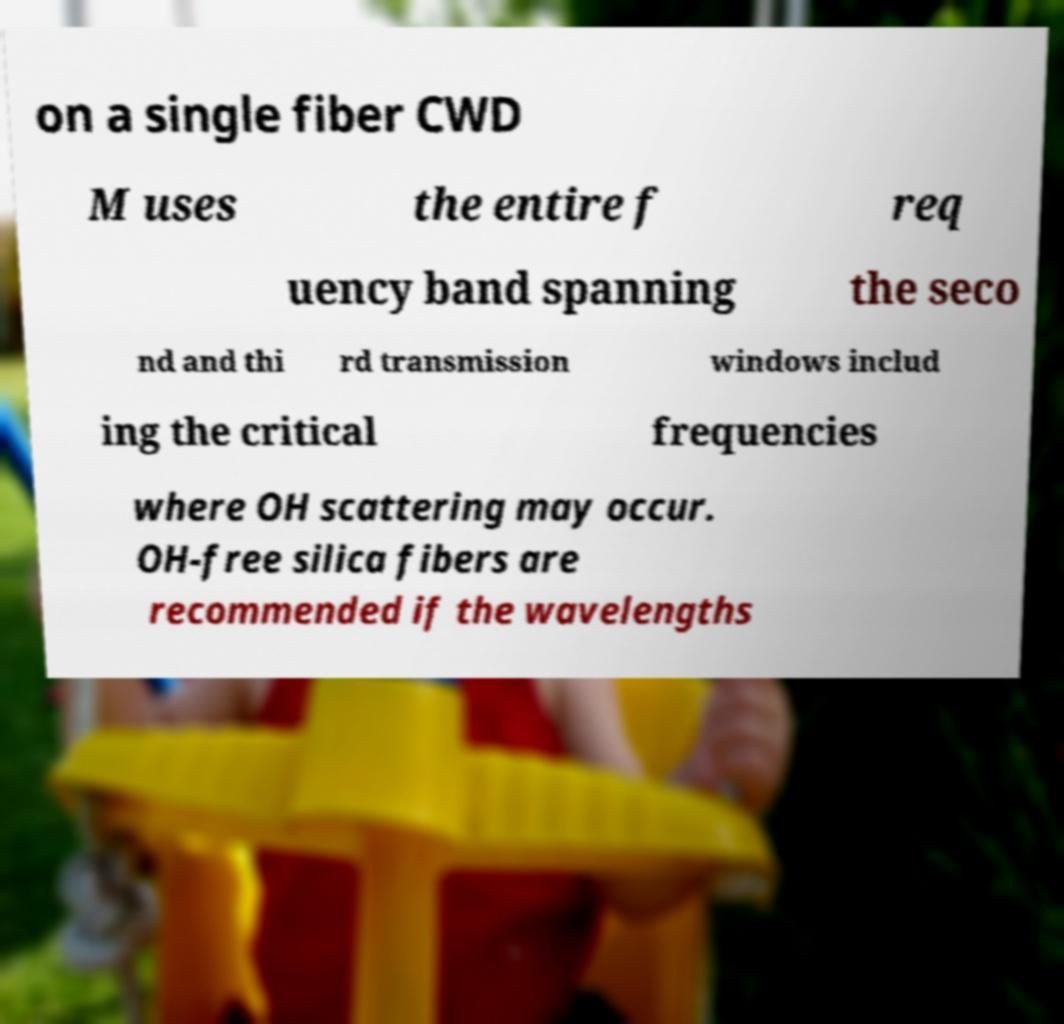Could you extract and type out the text from this image? on a single fiber CWD M uses the entire f req uency band spanning the seco nd and thi rd transmission windows includ ing the critical frequencies where OH scattering may occur. OH-free silica fibers are recommended if the wavelengths 